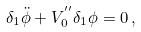Convert formula to latex. <formula><loc_0><loc_0><loc_500><loc_500>\delta _ { 1 } \ddot { \phi } + V _ { 0 } ^ { ^ { \prime \prime } } \delta _ { 1 } \phi = 0 \, ,</formula> 